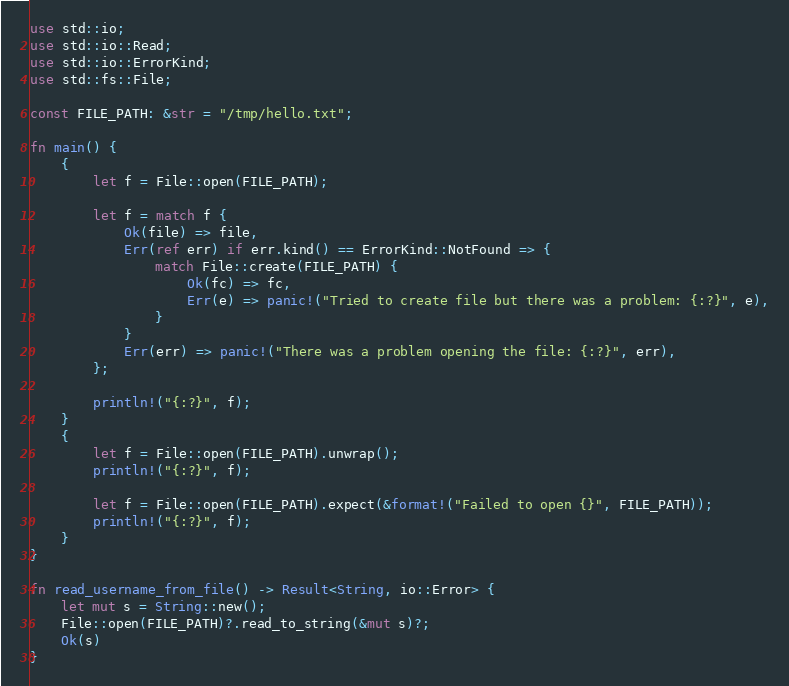Convert code to text. <code><loc_0><loc_0><loc_500><loc_500><_Rust_>use std::io;
use std::io::Read;
use std::io::ErrorKind;
use std::fs::File;

const FILE_PATH: &str = "/tmp/hello.txt";

fn main() {
    {
        let f = File::open(FILE_PATH);

        let f = match f {
            Ok(file) => file,
            Err(ref err) if err.kind() == ErrorKind::NotFound => {
                match File::create(FILE_PATH) {
                    Ok(fc) => fc,
                    Err(e) => panic!("Tried to create file but there was a problem: {:?}", e),
                }
            }
            Err(err) => panic!("There was a problem opening the file: {:?}", err),
        };

        println!("{:?}", f);
    }
    {
        let f = File::open(FILE_PATH).unwrap();
        println!("{:?}", f);

        let f = File::open(FILE_PATH).expect(&format!("Failed to open {}", FILE_PATH));
        println!("{:?}", f);
    }
}

fn read_username_from_file() -> Result<String, io::Error> {
    let mut s = String::new();
    File::open(FILE_PATH)?.read_to_string(&mut s)?;
    Ok(s)
}
</code> 